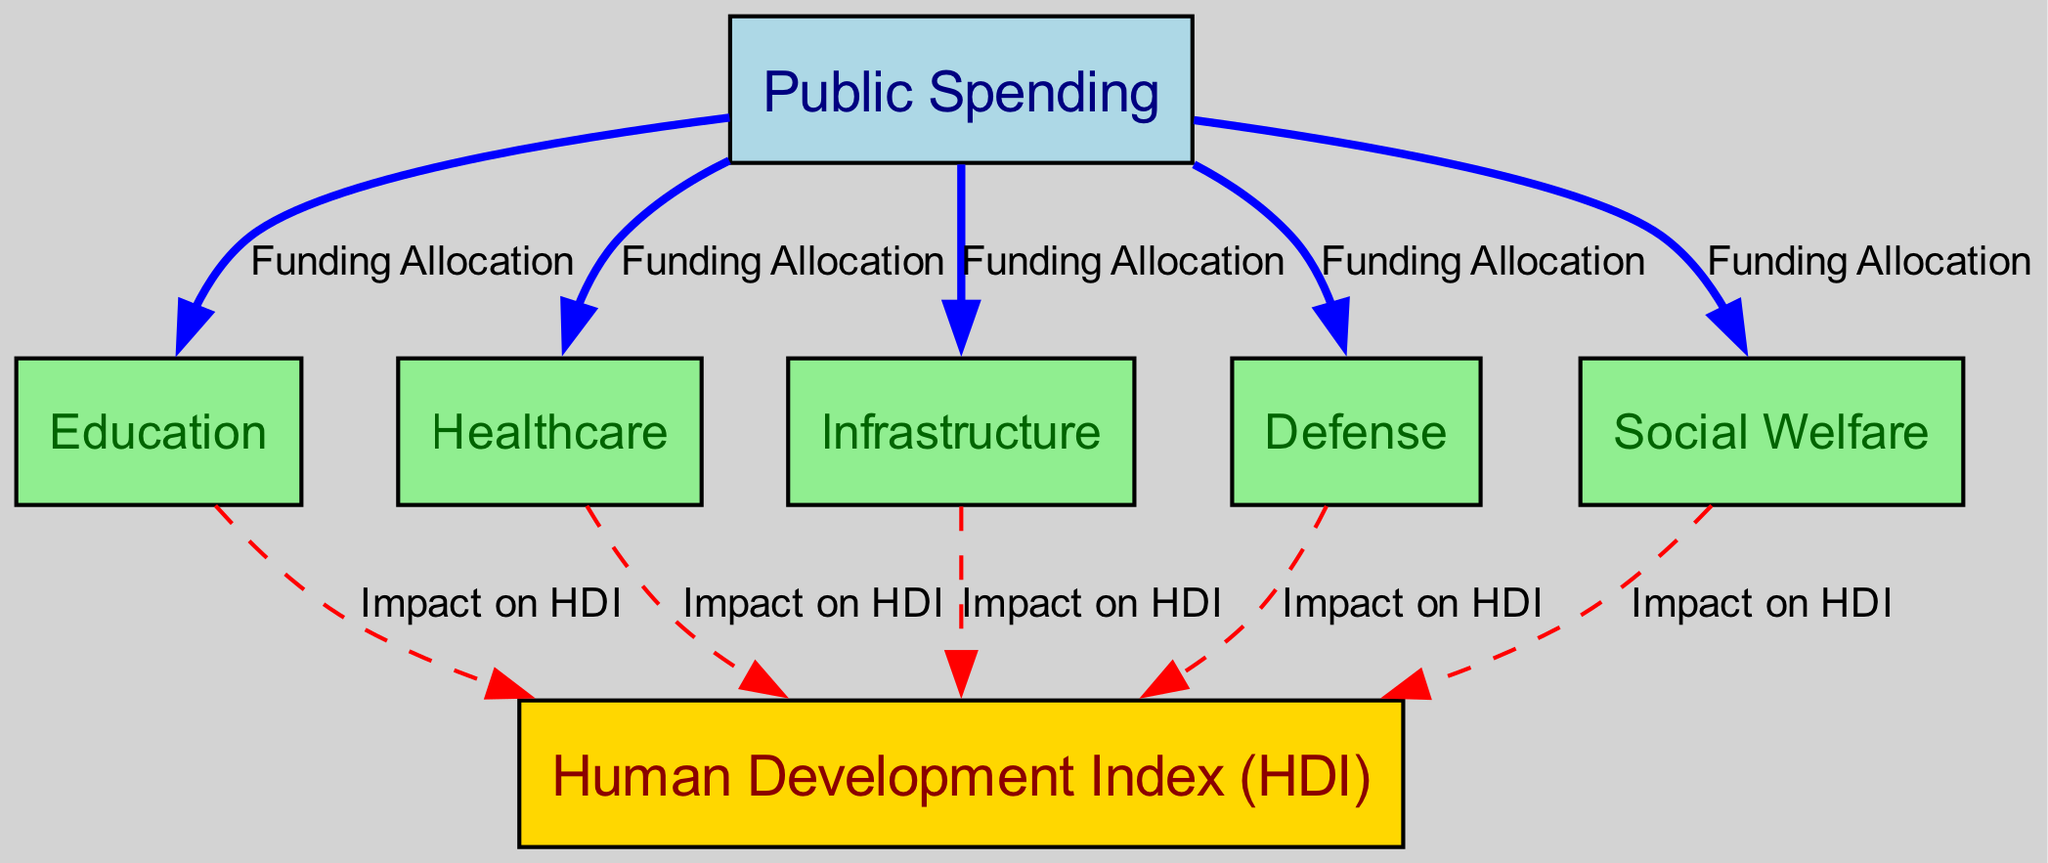What are the sectors receiving funding from public spending? The diagram illustrates that public spending is allocated to five sectors: Education, Healthcare, Infrastructure, Defense, and Social Welfare. Each sector is represented as a node connected to the Public Spending node, indicating direct funding allocation.
Answer: Education, Healthcare, Infrastructure, Defense, Social Welfare How many edges connect to the Human Development Index? In the diagram, the Human Development Index node has five incoming edges, each connecting from the five sectors (Education, Healthcare, Infrastructure, Defense, and Social Welfare). This shows how each sector impacts the index.
Answer: 5 What is the color of the Public Spending node? The Public Spending node is depicted in light blue, which indicates its significance as the starting point of funding allocation in the diagram.
Answer: Light blue Which sector has the strongest impact on the Human Development Index according to the diagram? All sectors (Education, Healthcare, Infrastructure, Defense, and Social Welfare) show an impact on the Human Development Index, represented by dashed lines. However, the diagram does not quantify the strength of this impact, making it difficult to determine which has the strongest effect based only on this diagram.
Answer: Not specified What is the relationship between Social Welfare and Human Development Index? The diagram shows a dashed line indicating an impact from the Social Welfare node to the Human Development Index. This connection signifies that Social Welfare contributes to enhancing the Human Development Index.
Answer: Impact on HDI How many nodes are connected directly to the Public Spending node? The Public Spending node is directly connected to five other nodes (Education, Healthcare, Infrastructure, Defense, and Social Welfare), indicating the sectors that receive funding from it.
Answer: 5 Which two sectors have the same type of impact representation on the Human Development Index? The sectors of Education and Healthcare both possess solid lines indicating a direct impact on the Human Development Index, as well as Infrastructure, Defense, and Social Welfare. They showcase a positive contribution to the HDI.
Answer: Education and Healthcare What is the main purpose of the diagram? The diagram aims to illustrate how public spending is allocated across different sectors and the effectiveness of this spending in achieving social and economic goals, represented through the Human Development Index.
Answer: Public spending efficiency illustration 